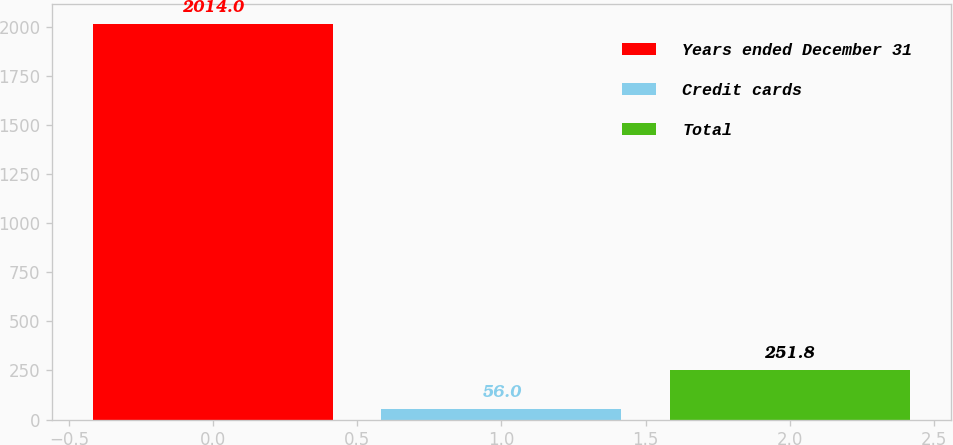Convert chart to OTSL. <chart><loc_0><loc_0><loc_500><loc_500><bar_chart><fcel>Years ended December 31<fcel>Credit cards<fcel>Total<nl><fcel>2014<fcel>56<fcel>251.8<nl></chart> 